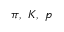Convert formula to latex. <formula><loc_0><loc_0><loc_500><loc_500>\pi , K , p</formula> 